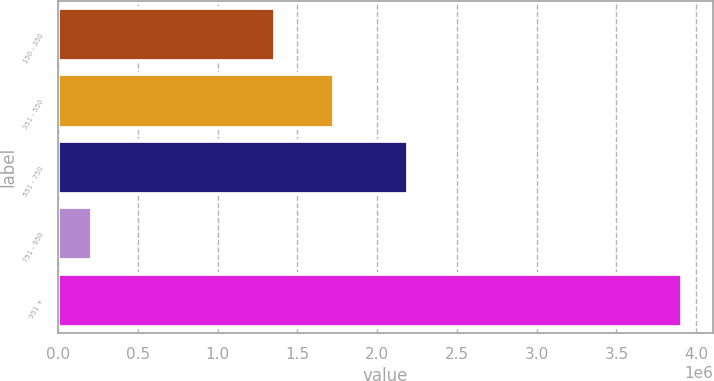Convert chart. <chart><loc_0><loc_0><loc_500><loc_500><bar_chart><fcel>150 - 350<fcel>351 - 550<fcel>551 - 750<fcel>751 - 950<fcel>951 +<nl><fcel>1.35754e+06<fcel>1.7271e+06<fcel>2.1938e+06<fcel>215666<fcel>3.91131e+06<nl></chart> 